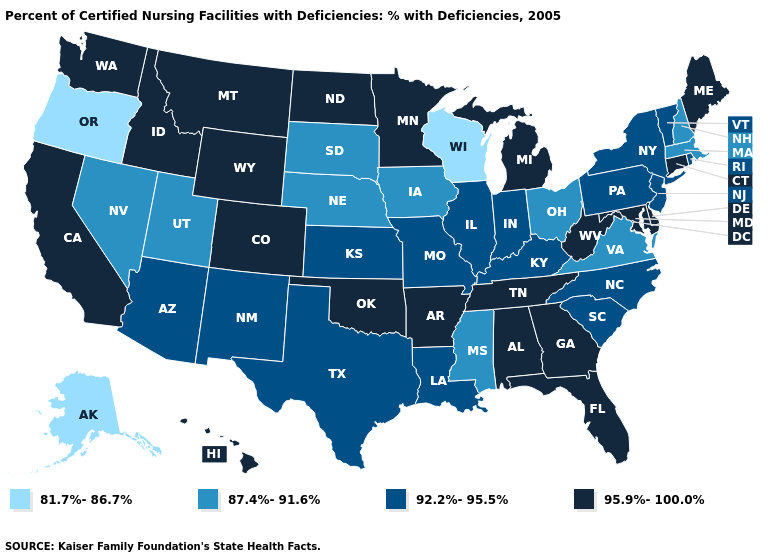Among the states that border Pennsylvania , does New York have the highest value?
Concise answer only. No. Among the states that border Oregon , which have the lowest value?
Give a very brief answer. Nevada. What is the value of Connecticut?
Give a very brief answer. 95.9%-100.0%. Does Hawaii have the lowest value in the USA?
Keep it brief. No. Name the states that have a value in the range 81.7%-86.7%?
Be succinct. Alaska, Oregon, Wisconsin. Does Nebraska have a higher value than Texas?
Answer briefly. No. Does West Virginia have the lowest value in the South?
Give a very brief answer. No. What is the value of Maryland?
Concise answer only. 95.9%-100.0%. What is the value of Pennsylvania?
Concise answer only. 92.2%-95.5%. What is the value of Washington?
Be succinct. 95.9%-100.0%. What is the highest value in the West ?
Keep it brief. 95.9%-100.0%. Name the states that have a value in the range 92.2%-95.5%?
Quick response, please. Arizona, Illinois, Indiana, Kansas, Kentucky, Louisiana, Missouri, New Jersey, New Mexico, New York, North Carolina, Pennsylvania, Rhode Island, South Carolina, Texas, Vermont. Among the states that border Kansas , does Oklahoma have the highest value?
Short answer required. Yes. Does Florida have the same value as Hawaii?
Short answer required. Yes. 